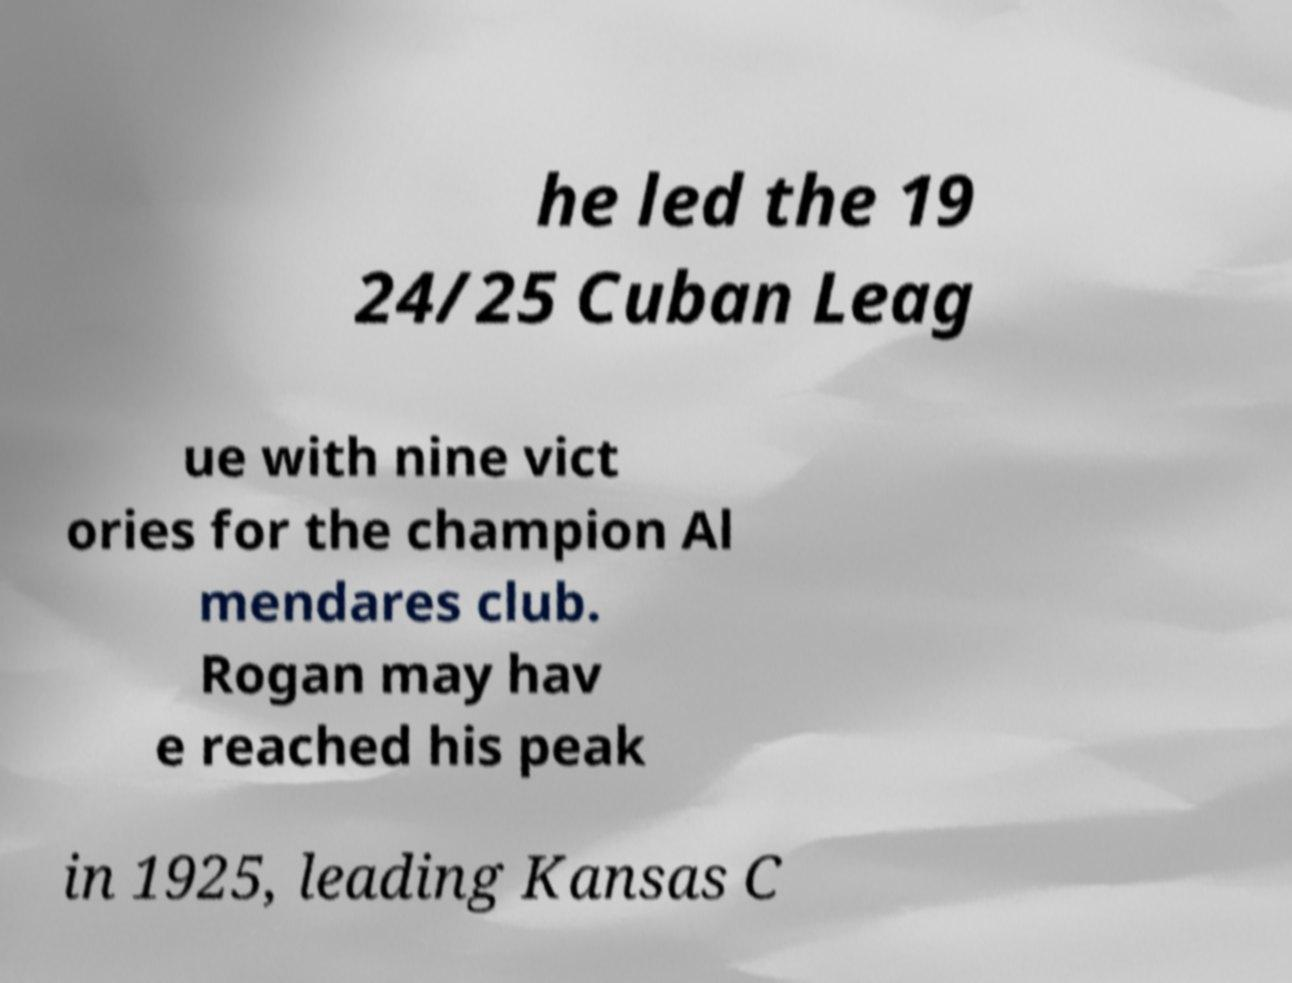I need the written content from this picture converted into text. Can you do that? he led the 19 24/25 Cuban Leag ue with nine vict ories for the champion Al mendares club. Rogan may hav e reached his peak in 1925, leading Kansas C 